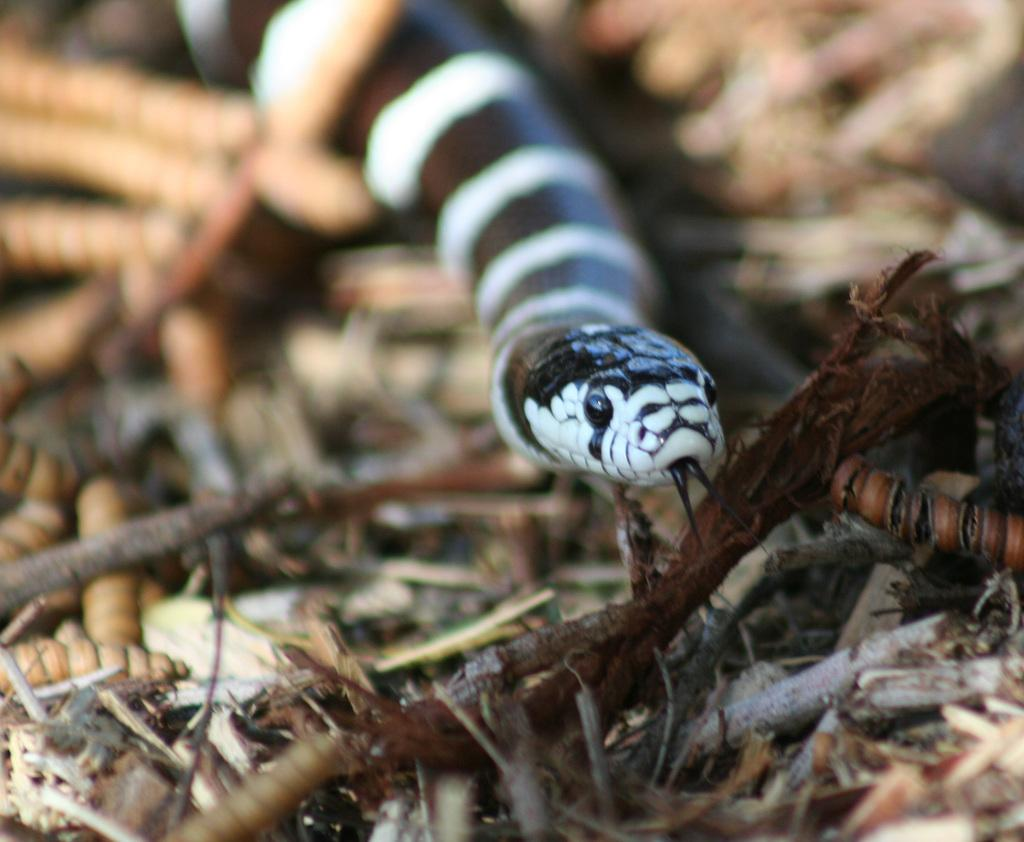What type of vegetation is present in the image? There is dried grass in the image. What else can be seen on the dried grass? There are twigs on the dried grass. What animal is present in the image? There is a snake in the image. Can you describe the appearance of the snake? The snake has brown and white lines on it. What grade does the snake receive on its performance in the image? There is no grading system or performance evaluation present in the image, as it is a photograph of a snake in its natural environment. 